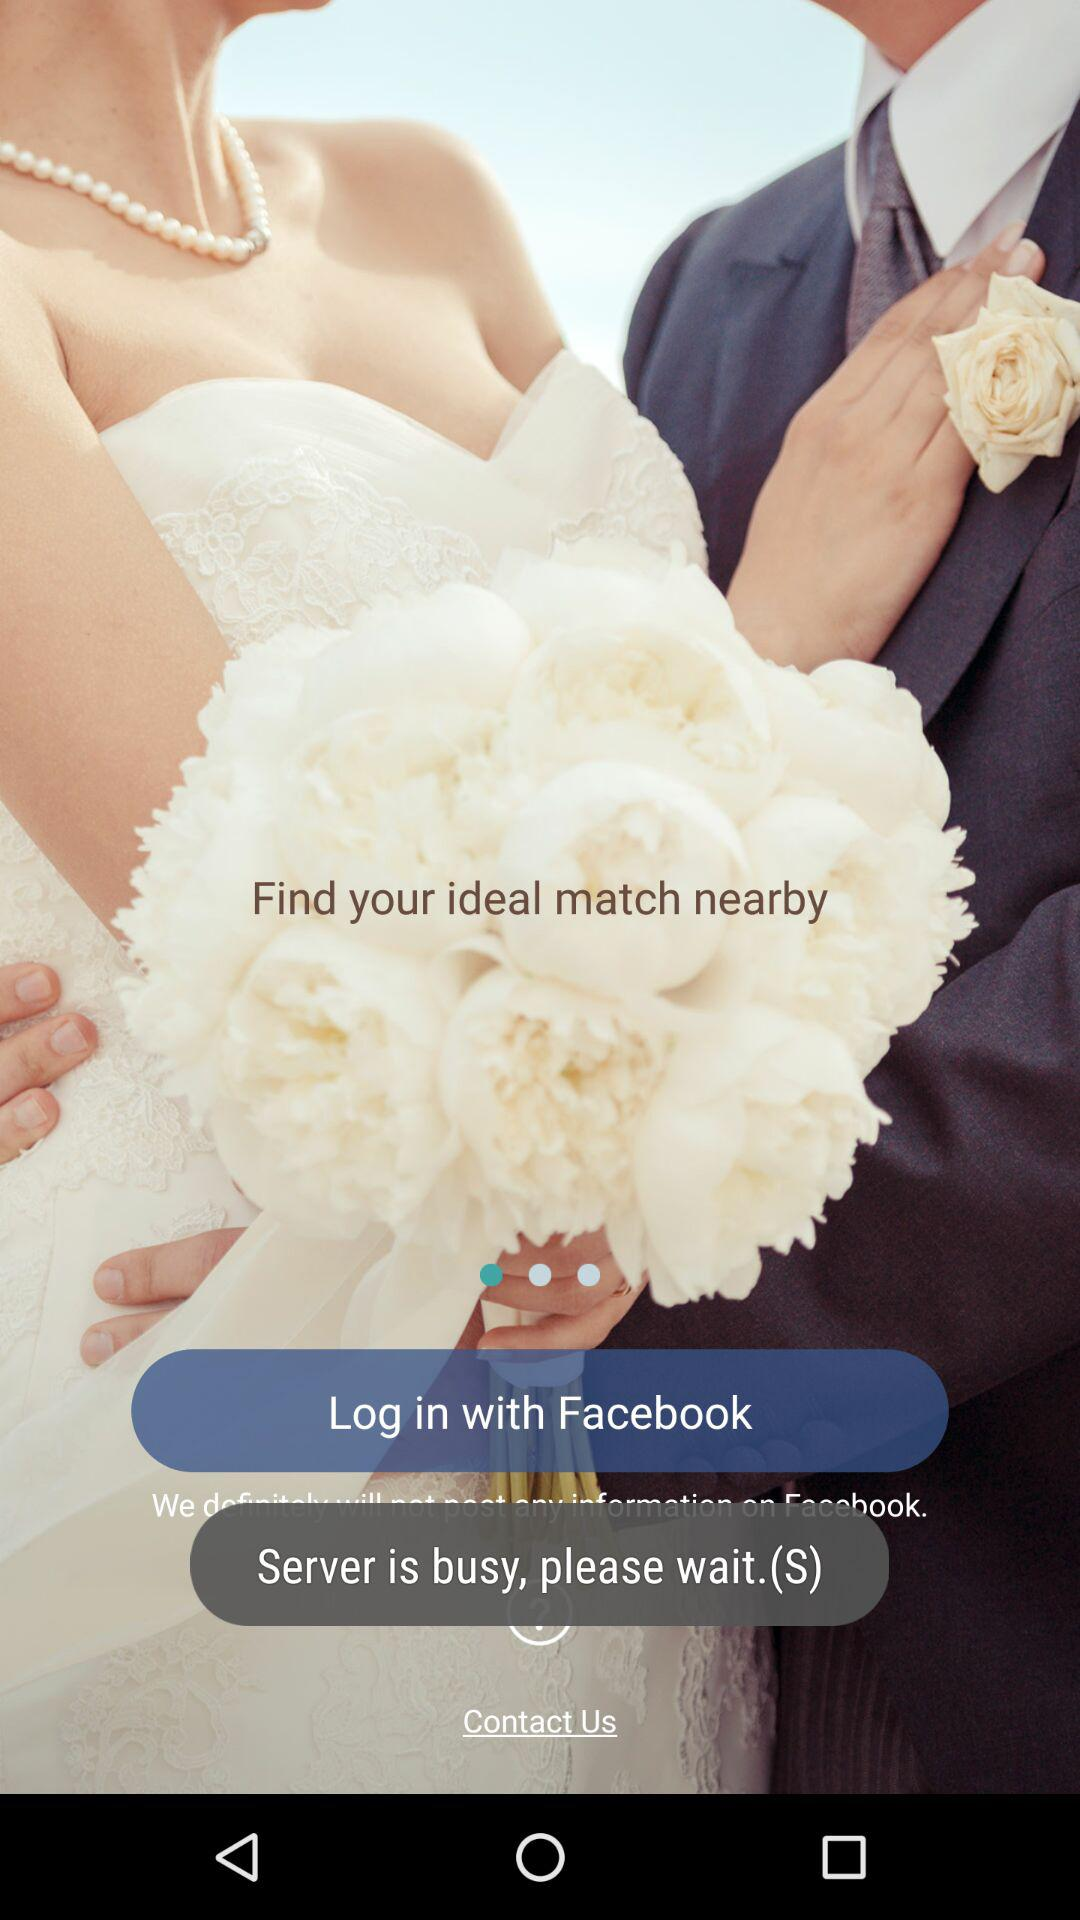What application can be used to log in? The application that can be used to log in is "Facebook". 